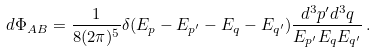<formula> <loc_0><loc_0><loc_500><loc_500>d \Phi _ { A B } = \frac { 1 } { 8 ( 2 \pi ) ^ { 5 } } \delta ( E _ { p } - E _ { p ^ { \prime } } - E _ { q } - E _ { q ^ { \prime } } ) \frac { d ^ { 3 } p ^ { \prime } d ^ { 3 } q } { E _ { p ^ { \prime } } E _ { q } E _ { q ^ { \prime } } } \, .</formula> 